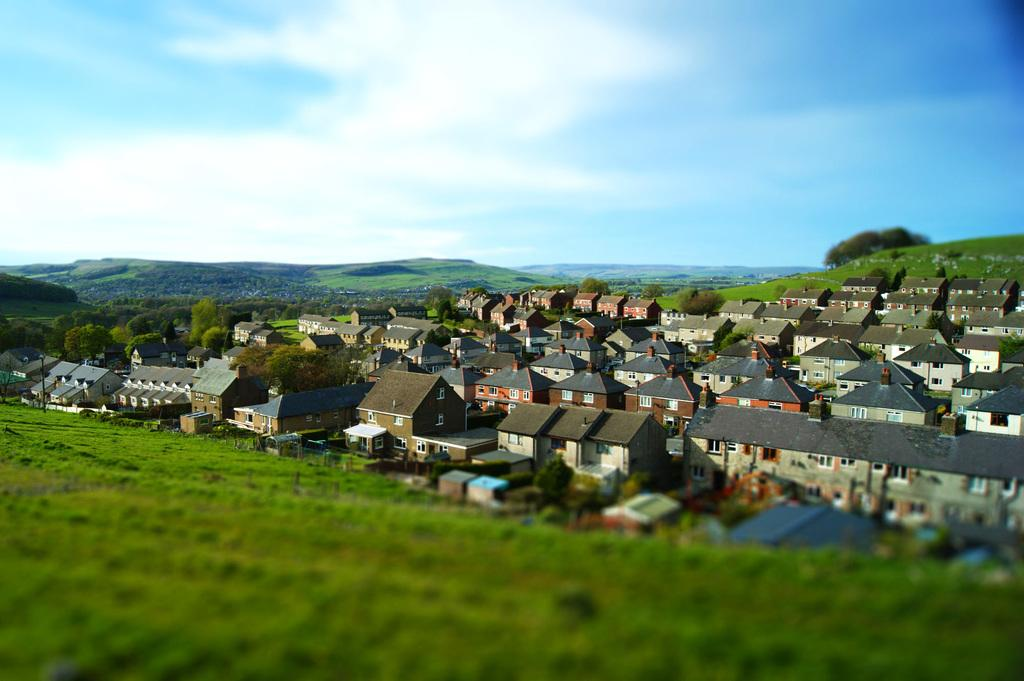What type of vegetation can be seen in the image? There is grass in the image. What type of structures are visible in the image? There are houses in the image. What other natural elements can be seen in the image? There are trees in the image. What can be seen in the distance in the image? There are mountains visible in the background of the image. How would you describe the sky in the image? The sky is clear in the background of the image. Can you tell me how many times the grandfather went on a voyage in the image? There is no grandfather or voyage mentioned in the image; it features grass, houses, trees, mountains, and a clear sky. What type of weather condition is present in the image due to the fog? There is no fog present in the image; the sky is clear. 